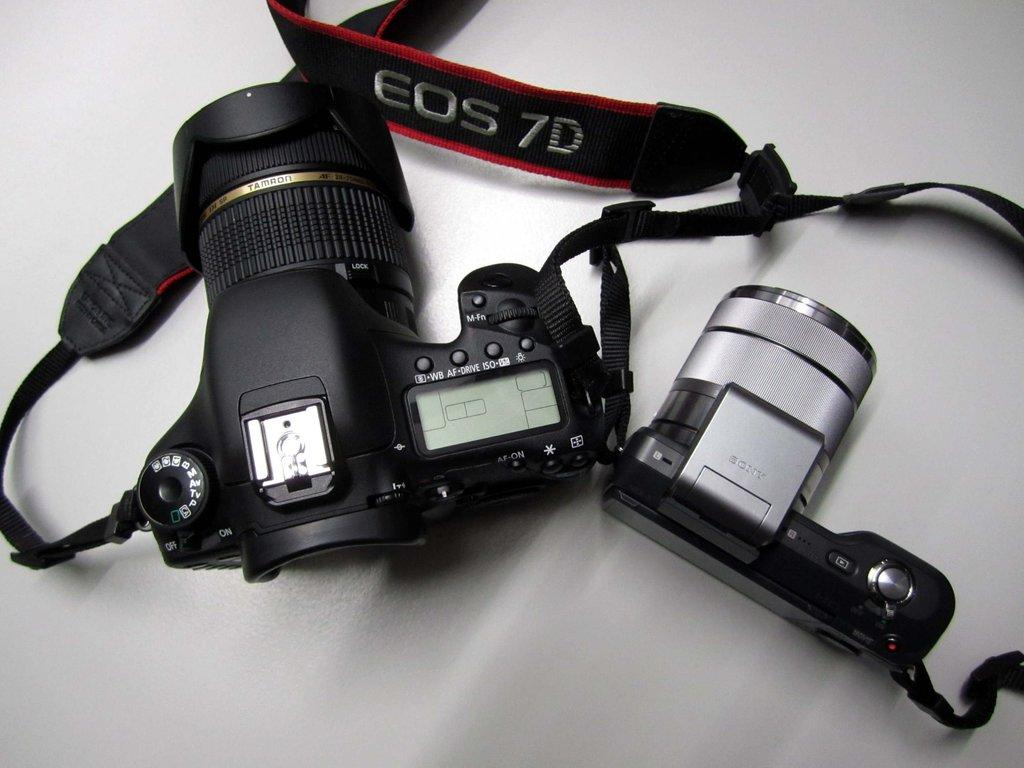What objects are present in the image? There are two cameras in the image. What color is the background of the image? The background of the image is white in color. What type of iron can be seen gripping the pail in the image? There is no iron or pail present in the image; it only features two cameras. 